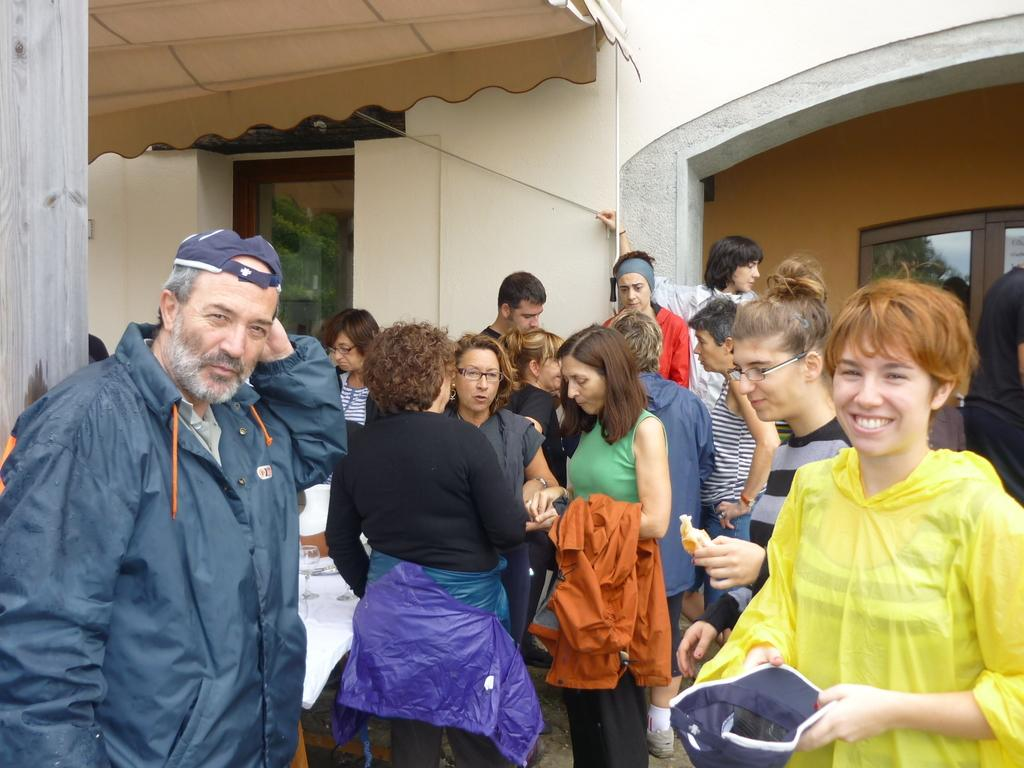Who or what can be seen in the image? There are people in the image. What can be seen in the distance behind the people? There is a building in the background of the image. Can you describe any specific features of the background? There is a window visible in the background of the image. What type of food is being prepared on the top of the building in the image? There is no food or cooking activity visible in the image, and the top of the building is not shown. 